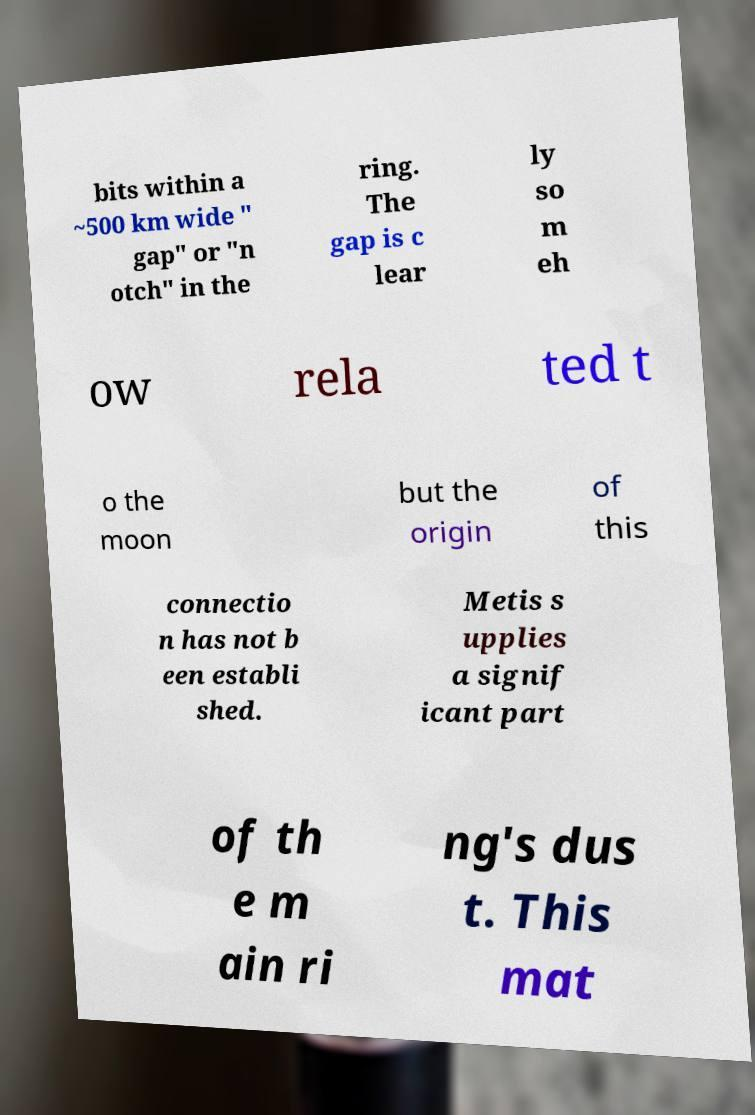Could you extract and type out the text from this image? bits within a ~500 km wide " gap" or "n otch" in the ring. The gap is c lear ly so m eh ow rela ted t o the moon but the origin of this connectio n has not b een establi shed. Metis s upplies a signif icant part of th e m ain ri ng's dus t. This mat 